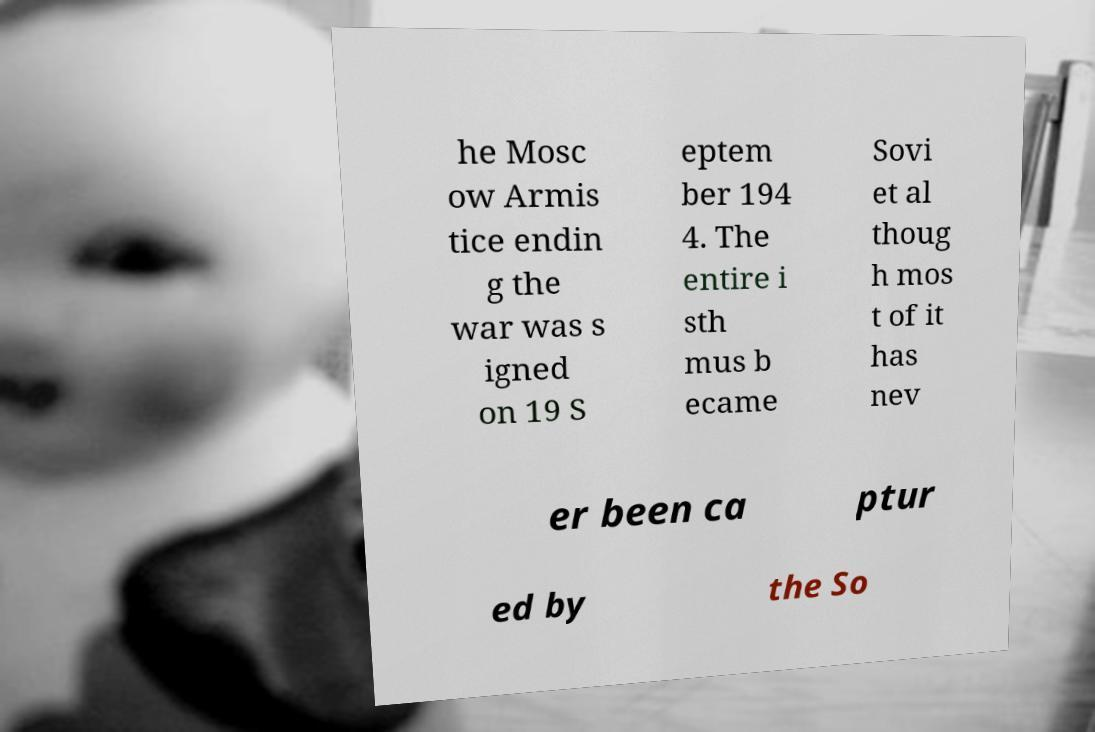There's text embedded in this image that I need extracted. Can you transcribe it verbatim? he Mosc ow Armis tice endin g the war was s igned on 19 S eptem ber 194 4. The entire i sth mus b ecame Sovi et al thoug h mos t of it has nev er been ca ptur ed by the So 